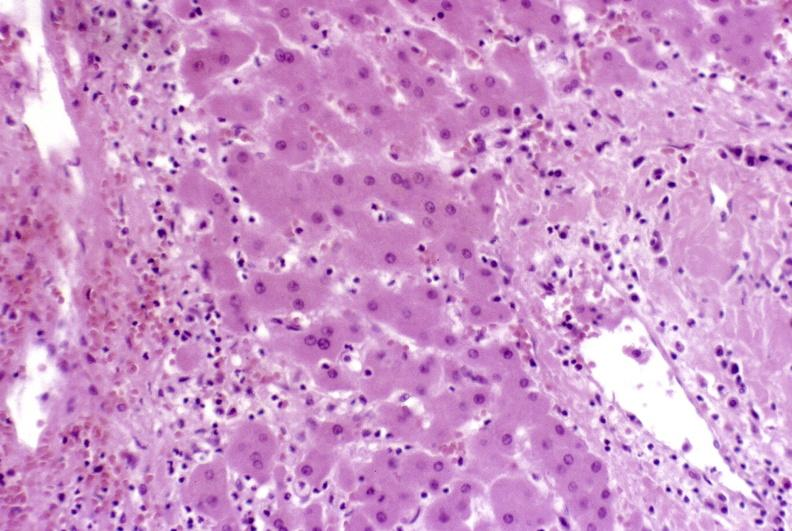s thecoma present?
Answer the question using a single word or phrase. No 